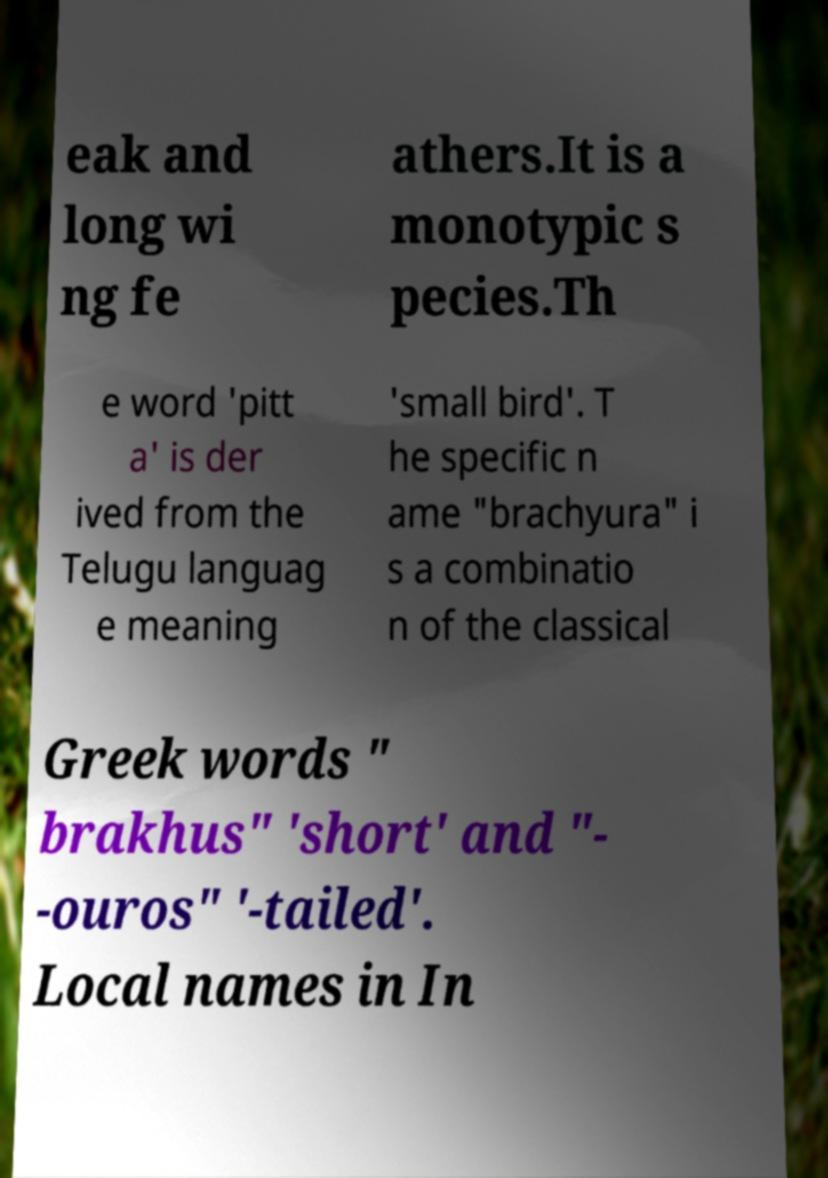Please read and relay the text visible in this image. What does it say? eak and long wi ng fe athers.It is a monotypic s pecies.Th e word 'pitt a' is der ived from the Telugu languag e meaning 'small bird'. T he specific n ame "brachyura" i s a combinatio n of the classical Greek words " brakhus" 'short' and "- -ouros" '-tailed'. Local names in In 